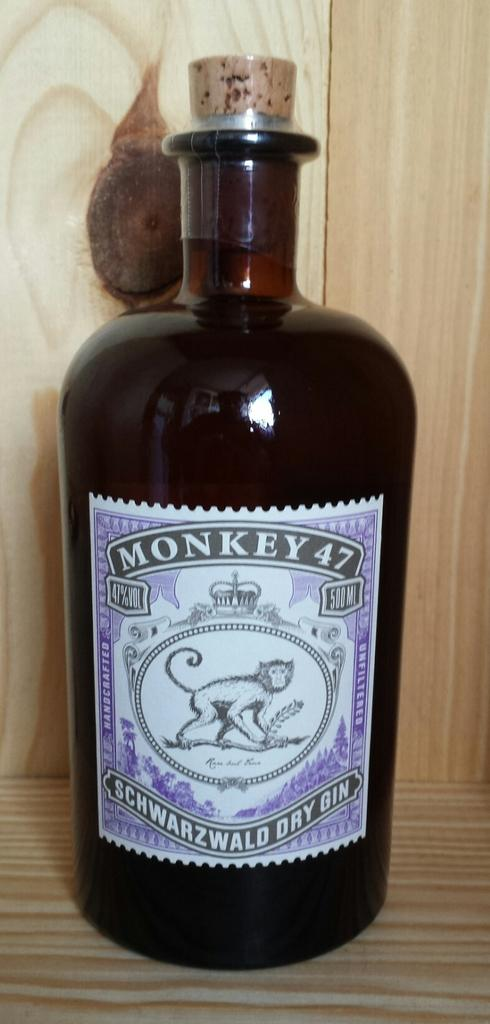Provide a one-sentence caption for the provided image. Dark bottle of Monkey 47 with a mokney on the label. 